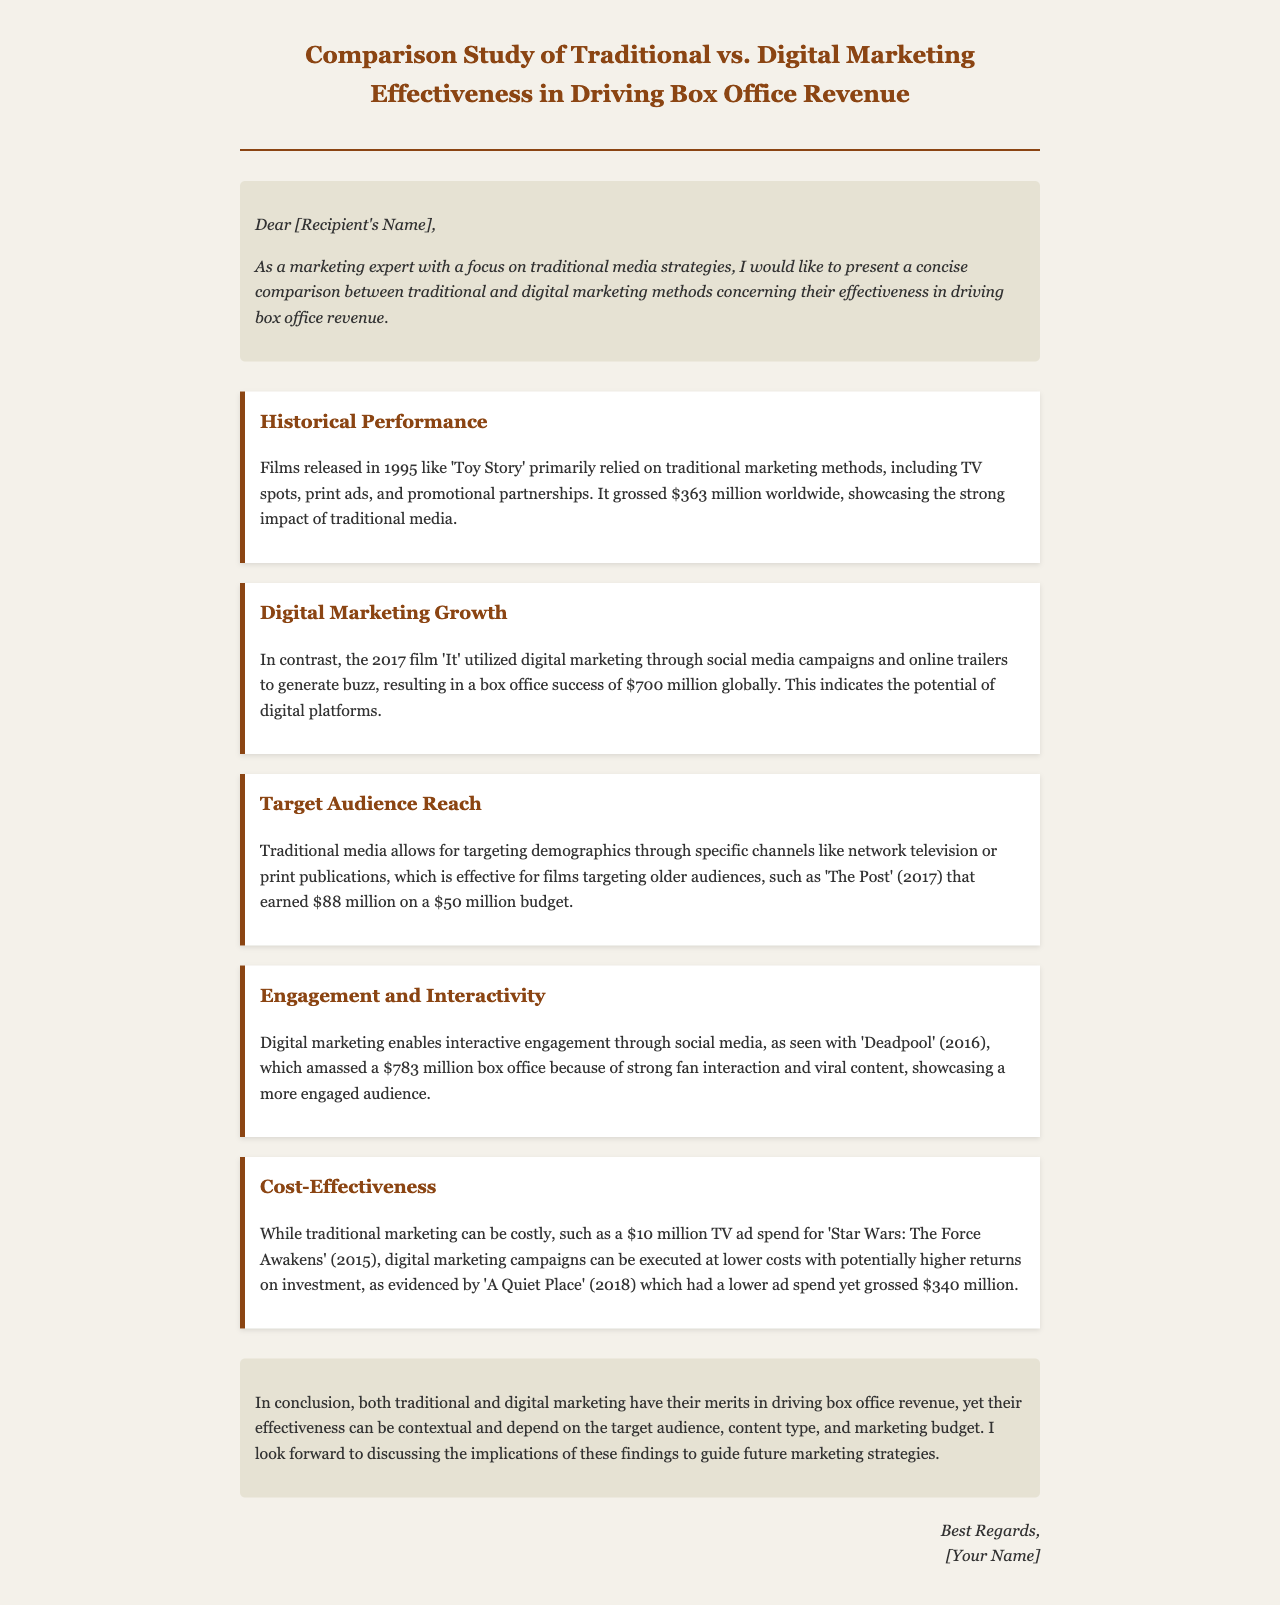What was the box office revenue for 'Toy Story'? The document states that 'Toy Story' grossed $363 million worldwide, demonstrating traditional media's impact.
Answer: $363 million Which marketing strategy was used for the film 'It'? The document mentions that 'It' utilized digital marketing through social media campaigns and online trailers.
Answer: Digital marketing What was the budget for 'The Post'? The budget for 'The Post' is specified as $50 million within the context of traditional marketing effectiveness.
Answer: $50 million How much did 'Deadpool' gross at the box office? The document reports that 'Deadpool' amassed $783 million due to strong fan interaction and viral content.
Answer: $783 million What specific cost is highlighted for 'Star Wars: The Force Awakens'? The document points out a $10 million TV ad spend as a cost associated with traditional marketing for 'Star Wars: The Force Awakens'.
Answer: $10 million Which year saw the film 'A Quiet Place' released? The document mentions that 'A Quiet Place' was released in 2018 and highlights its lower ad spend compared to box office returns.
Answer: 2018 What is the main conclusion about the effectiveness of marketing strategies? The conclusion emphasizes that the effectiveness of traditional and digital marketing is context-dependent based on multiple factors such as target audience.
Answer: Context-dependent Which marketing method was primarily used for films in 1995? The document indicates that traditional marketing methods were primarily relied upon for films released in 1995.
Answer: Traditional marketing What was the box office revenue of 'It'? The document mentions that 'It' achieved a box office success of $700 million globally.
Answer: $700 million 